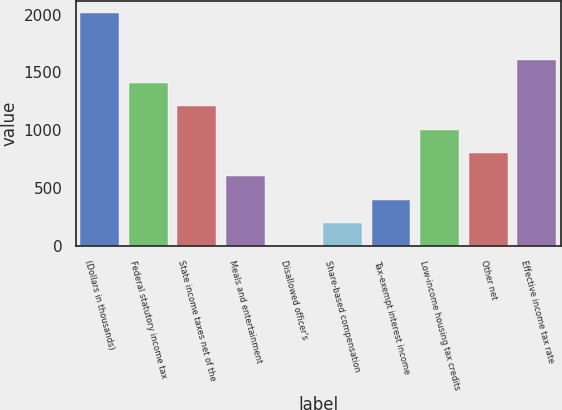Convert chart to OTSL. <chart><loc_0><loc_0><loc_500><loc_500><bar_chart><fcel>(Dollars in thousands)<fcel>Federal statutory income tax<fcel>State income taxes net of the<fcel>Meals and entertainment<fcel>Disallowed officer's<fcel>Share-based compensation<fcel>Tax-exempt interest income<fcel>Low-income housing tax credits<fcel>Other net<fcel>Effective income tax rate<nl><fcel>2013<fcel>1409.13<fcel>1207.84<fcel>603.97<fcel>0.1<fcel>201.39<fcel>402.68<fcel>1006.55<fcel>805.26<fcel>1610.42<nl></chart> 